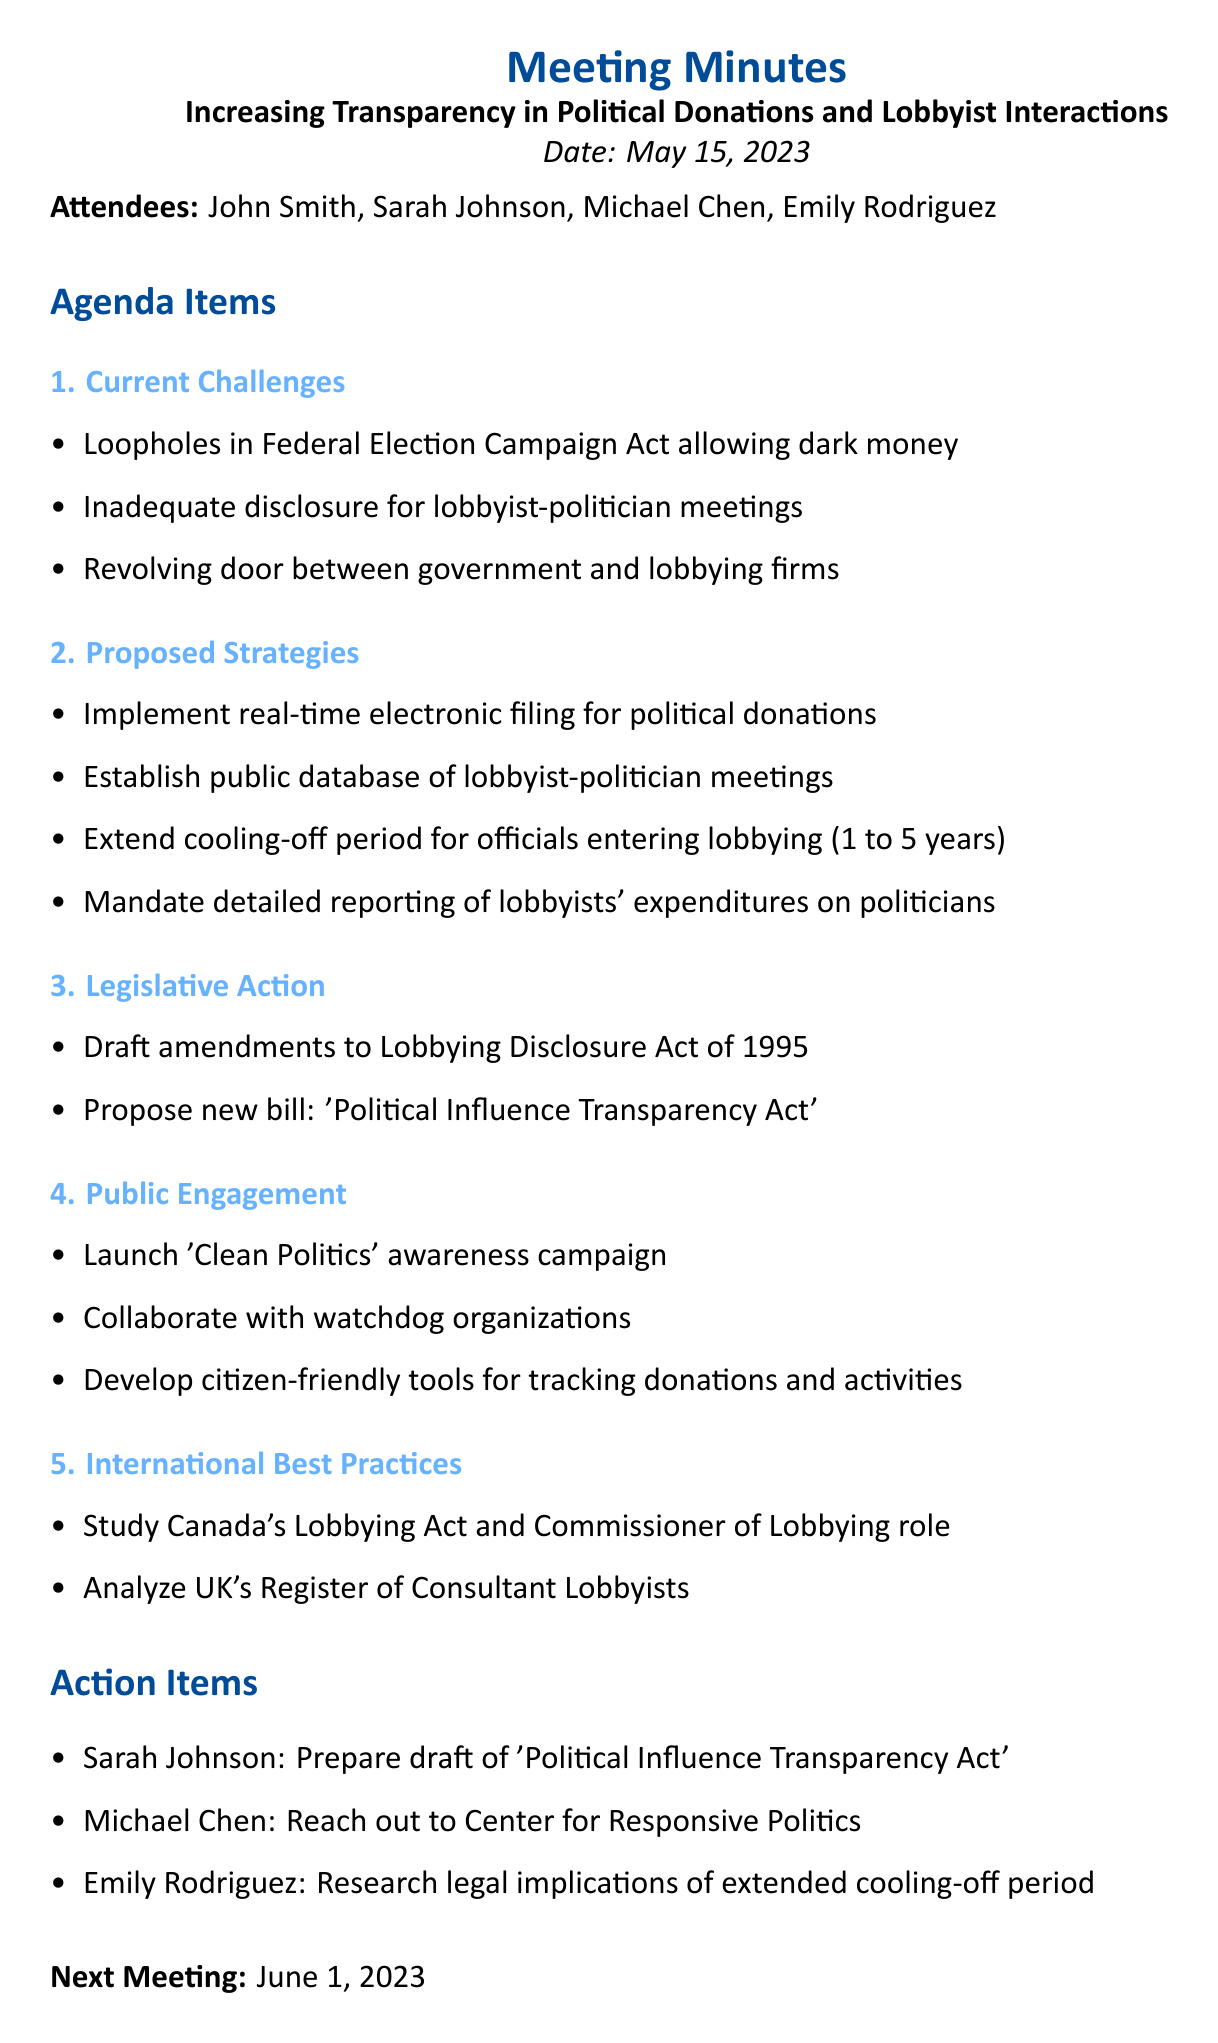What is the meeting title? The meeting title is the main subject discussed during the meeting, which is indicated at the beginning of the document.
Answer: Increasing Transparency in Political Donations and Lobbyist Interactions Who is the Director of the Ethics Commission? The Director of the Ethics Commission is one of the attendees listed in the document, specifically named in the attendees section.
Answer: Sarah Johnson What is the date of the next meeting? The next meeting date is provided explicitly in the document as a future date after the current meeting.
Answer: June 1, 2023 What is one of the current challenges mentioned? This refers to one of the specific issues highlighted during the meeting under the agenda item regarding challenges faced.
Answer: Loopholes in Federal Election Campaign Act allowing dark money What is the proposed cooling-off period extension for government officials entering lobbying? This question refers to a specific numerical change proposed during the discussions in the document.
Answer: 5 years Who is responsible for preparing the draft of the 'Political Influence Transparency Act'? This action item assigns a specific task to one of the attendees of the meeting, identified under the action items section.
Answer: Sarah Johnson What is the proposed new bill mentioned in the document? This question focuses on a legislative proposal highlighted in the meeting minutes that aims at improving transparency.
Answer: Political Influence Transparency Act What organization is mentioned for collaboration regarding public engagement? This question looks for the specific organization noted in the public engagement section aimed at collaboration.
Answer: Center for Responsive Politics What type of campaign is being launched for public engagement? This question seeks to identify a specific initiative mentioned in the document aimed at increasing awareness and engagement from the public.
Answer: Clean Politics 